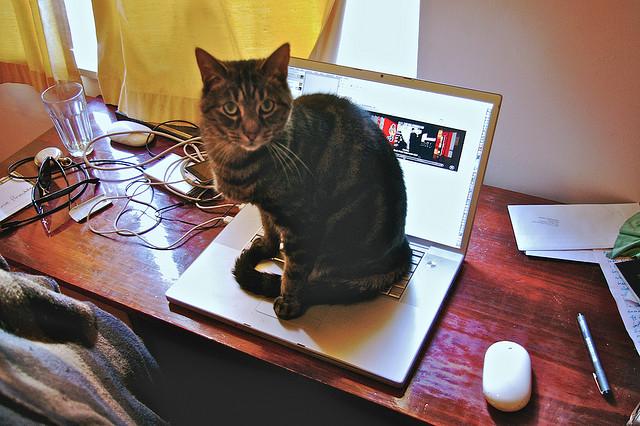Is the cat looking at the camera?
Answer briefly. Yes. What is the brand is the computer mouse?
Answer briefly. Apple. Is the mouse wireless?
Be succinct. Yes. Would the cat want to eat the mouse pictured?
Concise answer only. No. Is this cat looking at the computer mouse?
Write a very short answer. No. 